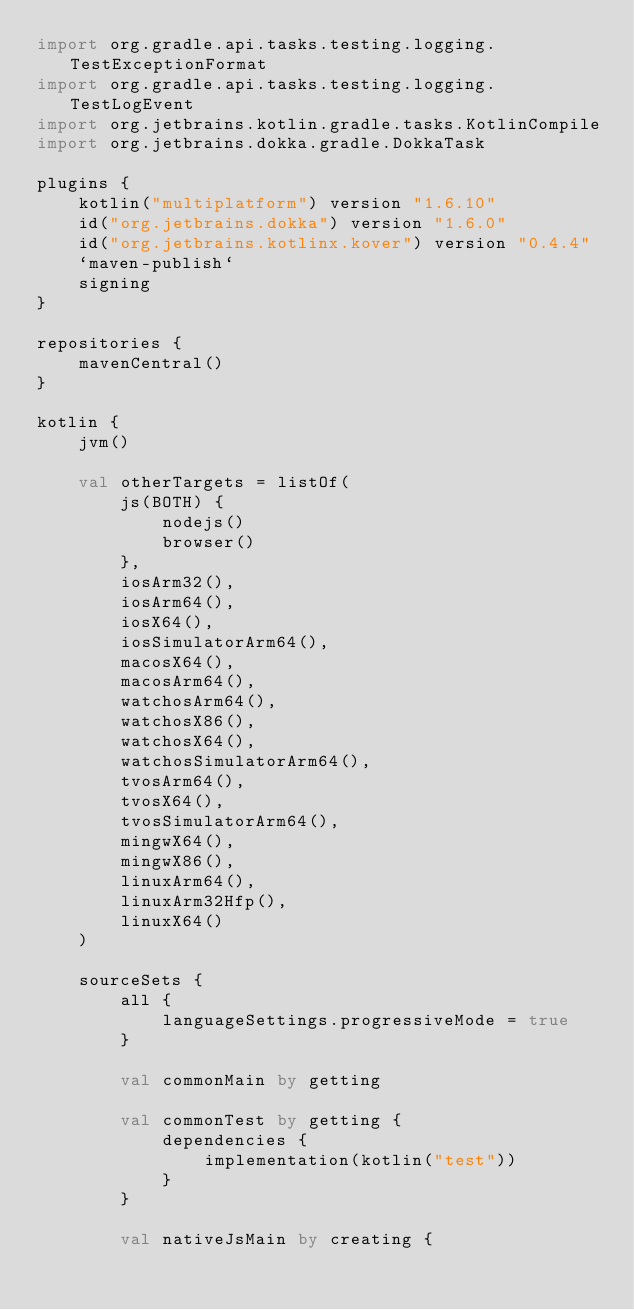<code> <loc_0><loc_0><loc_500><loc_500><_Kotlin_>import org.gradle.api.tasks.testing.logging.TestExceptionFormat
import org.gradle.api.tasks.testing.logging.TestLogEvent
import org.jetbrains.kotlin.gradle.tasks.KotlinCompile
import org.jetbrains.dokka.gradle.DokkaTask

plugins {
    kotlin("multiplatform") version "1.6.10"
    id("org.jetbrains.dokka") version "1.6.0"
    id("org.jetbrains.kotlinx.kover") version "0.4.4"
    `maven-publish`
    signing
}

repositories {
    mavenCentral()
}

kotlin {
    jvm()

    val otherTargets = listOf(
        js(BOTH) {
            nodejs()
            browser()
        },
        iosArm32(),
        iosArm64(),
        iosX64(),
        iosSimulatorArm64(),
        macosX64(),
        macosArm64(),
        watchosArm64(),
        watchosX86(),
        watchosX64(),
        watchosSimulatorArm64(),
        tvosArm64(),
        tvosX64(),
        tvosSimulatorArm64(),
        mingwX64(),
        mingwX86(),
        linuxArm64(),
        linuxArm32Hfp(),
        linuxX64()
    )

    sourceSets {
        all {
            languageSettings.progressiveMode = true
        }

        val commonMain by getting

        val commonTest by getting {
            dependencies {
                implementation(kotlin("test"))
            }
        }

        val nativeJsMain by creating {</code> 